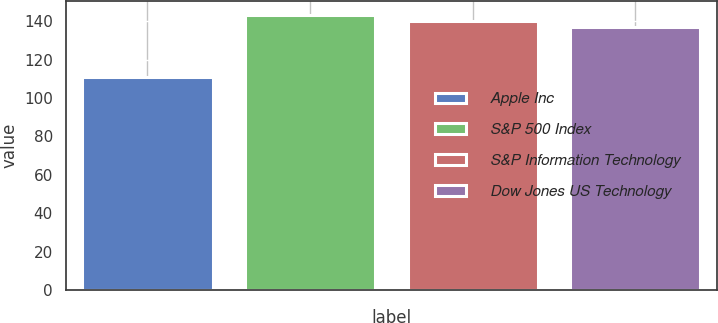Convert chart to OTSL. <chart><loc_0><loc_0><loc_500><loc_500><bar_chart><fcel>Apple Inc<fcel>S&P 500 Index<fcel>S&P Information Technology<fcel>Dow Jones US Technology<nl><fcel>111<fcel>143.4<fcel>140.2<fcel>137<nl></chart> 